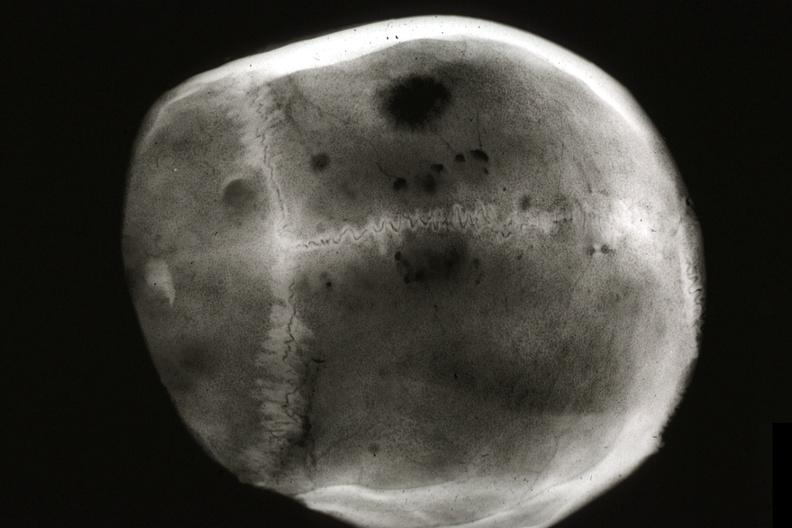what is present?
Answer the question using a single word or phrase. Bone, skull 